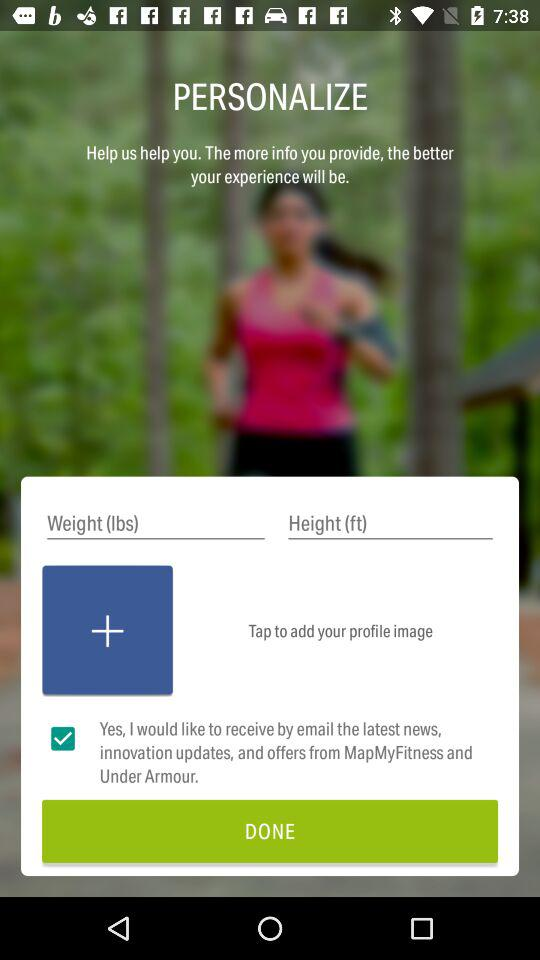What is the unit of weight? The unit of weight is lbs. 